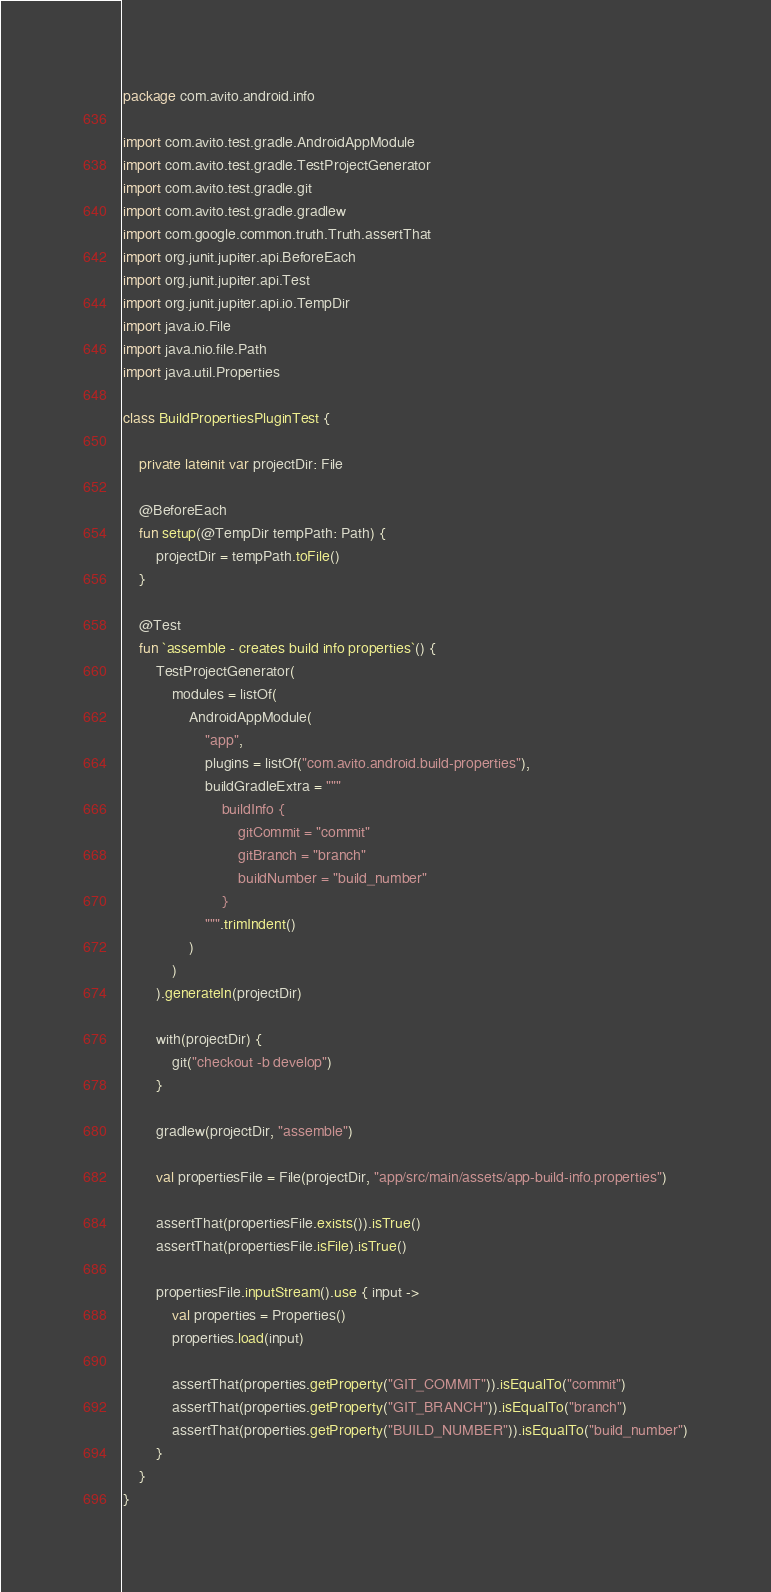Convert code to text. <code><loc_0><loc_0><loc_500><loc_500><_Kotlin_>package com.avito.android.info

import com.avito.test.gradle.AndroidAppModule
import com.avito.test.gradle.TestProjectGenerator
import com.avito.test.gradle.git
import com.avito.test.gradle.gradlew
import com.google.common.truth.Truth.assertThat
import org.junit.jupiter.api.BeforeEach
import org.junit.jupiter.api.Test
import org.junit.jupiter.api.io.TempDir
import java.io.File
import java.nio.file.Path
import java.util.Properties

class BuildPropertiesPluginTest {

    private lateinit var projectDir: File

    @BeforeEach
    fun setup(@TempDir tempPath: Path) {
        projectDir = tempPath.toFile()
    }

    @Test
    fun `assemble - creates build info properties`() {
        TestProjectGenerator(
            modules = listOf(
                AndroidAppModule(
                    "app",
                    plugins = listOf("com.avito.android.build-properties"),
                    buildGradleExtra = """
                        buildInfo {
                            gitCommit = "commit"
                            gitBranch = "branch"
                            buildNumber = "build_number"
                        }
                    """.trimIndent()
                )
            )
        ).generateIn(projectDir)

        with(projectDir) {
            git("checkout -b develop")
        }

        gradlew(projectDir, "assemble")
        
        val propertiesFile = File(projectDir, "app/src/main/assets/app-build-info.properties")

        assertThat(propertiesFile.exists()).isTrue()
        assertThat(propertiesFile.isFile).isTrue()

        propertiesFile.inputStream().use { input ->
            val properties = Properties()
            properties.load(input)

            assertThat(properties.getProperty("GIT_COMMIT")).isEqualTo("commit")
            assertThat(properties.getProperty("GIT_BRANCH")).isEqualTo("branch")
            assertThat(properties.getProperty("BUILD_NUMBER")).isEqualTo("build_number")
        }
    }
}
</code> 